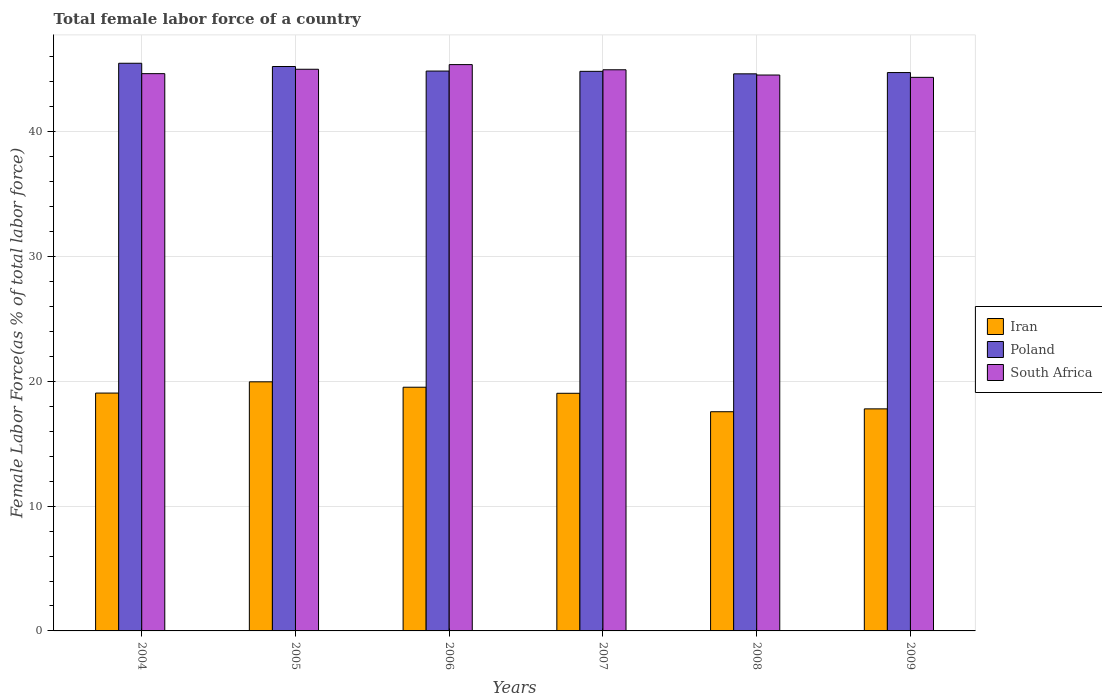How many groups of bars are there?
Your answer should be compact. 6. Are the number of bars on each tick of the X-axis equal?
Make the answer very short. Yes. How many bars are there on the 2nd tick from the left?
Offer a very short reply. 3. In how many cases, is the number of bars for a given year not equal to the number of legend labels?
Your response must be concise. 0. What is the percentage of female labor force in Poland in 2005?
Offer a terse response. 45.23. Across all years, what is the maximum percentage of female labor force in South Africa?
Make the answer very short. 45.38. Across all years, what is the minimum percentage of female labor force in Iran?
Your answer should be very brief. 17.56. In which year was the percentage of female labor force in Iran maximum?
Give a very brief answer. 2005. In which year was the percentage of female labor force in South Africa minimum?
Give a very brief answer. 2009. What is the total percentage of female labor force in Iran in the graph?
Your answer should be compact. 112.95. What is the difference between the percentage of female labor force in Iran in 2007 and that in 2008?
Ensure brevity in your answer.  1.48. What is the difference between the percentage of female labor force in Iran in 2008 and the percentage of female labor force in South Africa in 2006?
Offer a very short reply. -27.82. What is the average percentage of female labor force in South Africa per year?
Give a very brief answer. 44.82. In the year 2004, what is the difference between the percentage of female labor force in South Africa and percentage of female labor force in Iran?
Offer a very short reply. 25.6. In how many years, is the percentage of female labor force in Poland greater than 24 %?
Keep it short and to the point. 6. What is the ratio of the percentage of female labor force in South Africa in 2006 to that in 2007?
Offer a very short reply. 1.01. Is the percentage of female labor force in Iran in 2005 less than that in 2008?
Offer a terse response. No. Is the difference between the percentage of female labor force in South Africa in 2006 and 2009 greater than the difference between the percentage of female labor force in Iran in 2006 and 2009?
Offer a very short reply. No. What is the difference between the highest and the second highest percentage of female labor force in South Africa?
Your answer should be compact. 0.37. What is the difference between the highest and the lowest percentage of female labor force in South Africa?
Make the answer very short. 1.02. In how many years, is the percentage of female labor force in South Africa greater than the average percentage of female labor force in South Africa taken over all years?
Provide a succinct answer. 3. Is the sum of the percentage of female labor force in Iran in 2006 and 2008 greater than the maximum percentage of female labor force in South Africa across all years?
Offer a terse response. No. What does the 2nd bar from the left in 2004 represents?
Provide a short and direct response. Poland. What does the 3rd bar from the right in 2005 represents?
Ensure brevity in your answer.  Iran. Is it the case that in every year, the sum of the percentage of female labor force in Iran and percentage of female labor force in South Africa is greater than the percentage of female labor force in Poland?
Offer a very short reply. Yes. How many bars are there?
Ensure brevity in your answer.  18. Does the graph contain any zero values?
Give a very brief answer. No. What is the title of the graph?
Your answer should be very brief. Total female labor force of a country. What is the label or title of the X-axis?
Provide a short and direct response. Years. What is the label or title of the Y-axis?
Offer a very short reply. Female Labor Force(as % of total labor force). What is the Female Labor Force(as % of total labor force) of Iran in 2004?
Provide a succinct answer. 19.06. What is the Female Labor Force(as % of total labor force) of Poland in 2004?
Your answer should be compact. 45.49. What is the Female Labor Force(as % of total labor force) in South Africa in 2004?
Give a very brief answer. 44.66. What is the Female Labor Force(as % of total labor force) of Iran in 2005?
Make the answer very short. 19.96. What is the Female Labor Force(as % of total labor force) in Poland in 2005?
Give a very brief answer. 45.23. What is the Female Labor Force(as % of total labor force) in South Africa in 2005?
Your response must be concise. 45.01. What is the Female Labor Force(as % of total labor force) of Iran in 2006?
Offer a very short reply. 19.53. What is the Female Labor Force(as % of total labor force) in Poland in 2006?
Offer a very short reply. 44.86. What is the Female Labor Force(as % of total labor force) of South Africa in 2006?
Keep it short and to the point. 45.38. What is the Female Labor Force(as % of total labor force) of Iran in 2007?
Offer a terse response. 19.04. What is the Female Labor Force(as % of total labor force) of Poland in 2007?
Your answer should be compact. 44.84. What is the Female Labor Force(as % of total labor force) in South Africa in 2007?
Your answer should be very brief. 44.97. What is the Female Labor Force(as % of total labor force) of Iran in 2008?
Provide a short and direct response. 17.56. What is the Female Labor Force(as % of total labor force) in Poland in 2008?
Your answer should be very brief. 44.64. What is the Female Labor Force(as % of total labor force) in South Africa in 2008?
Ensure brevity in your answer.  44.54. What is the Female Labor Force(as % of total labor force) of Iran in 2009?
Give a very brief answer. 17.79. What is the Female Labor Force(as % of total labor force) in Poland in 2009?
Make the answer very short. 44.74. What is the Female Labor Force(as % of total labor force) of South Africa in 2009?
Make the answer very short. 44.36. Across all years, what is the maximum Female Labor Force(as % of total labor force) of Iran?
Offer a terse response. 19.96. Across all years, what is the maximum Female Labor Force(as % of total labor force) in Poland?
Your answer should be very brief. 45.49. Across all years, what is the maximum Female Labor Force(as % of total labor force) in South Africa?
Make the answer very short. 45.38. Across all years, what is the minimum Female Labor Force(as % of total labor force) of Iran?
Offer a very short reply. 17.56. Across all years, what is the minimum Female Labor Force(as % of total labor force) of Poland?
Offer a very short reply. 44.64. Across all years, what is the minimum Female Labor Force(as % of total labor force) of South Africa?
Provide a succinct answer. 44.36. What is the total Female Labor Force(as % of total labor force) in Iran in the graph?
Offer a terse response. 112.95. What is the total Female Labor Force(as % of total labor force) of Poland in the graph?
Provide a short and direct response. 269.8. What is the total Female Labor Force(as % of total labor force) of South Africa in the graph?
Offer a very short reply. 268.91. What is the difference between the Female Labor Force(as % of total labor force) of Iran in 2004 and that in 2005?
Ensure brevity in your answer.  -0.9. What is the difference between the Female Labor Force(as % of total labor force) in Poland in 2004 and that in 2005?
Your answer should be compact. 0.26. What is the difference between the Female Labor Force(as % of total labor force) in South Africa in 2004 and that in 2005?
Give a very brief answer. -0.35. What is the difference between the Female Labor Force(as % of total labor force) in Iran in 2004 and that in 2006?
Provide a succinct answer. -0.47. What is the difference between the Female Labor Force(as % of total labor force) in Poland in 2004 and that in 2006?
Give a very brief answer. 0.63. What is the difference between the Female Labor Force(as % of total labor force) of South Africa in 2004 and that in 2006?
Provide a succinct answer. -0.72. What is the difference between the Female Labor Force(as % of total labor force) of Iran in 2004 and that in 2007?
Your response must be concise. 0.02. What is the difference between the Female Labor Force(as % of total labor force) in Poland in 2004 and that in 2007?
Make the answer very short. 0.65. What is the difference between the Female Labor Force(as % of total labor force) in South Africa in 2004 and that in 2007?
Give a very brief answer. -0.31. What is the difference between the Female Labor Force(as % of total labor force) of Iran in 2004 and that in 2008?
Make the answer very short. 1.5. What is the difference between the Female Labor Force(as % of total labor force) of Poland in 2004 and that in 2008?
Offer a terse response. 0.85. What is the difference between the Female Labor Force(as % of total labor force) of South Africa in 2004 and that in 2008?
Give a very brief answer. 0.11. What is the difference between the Female Labor Force(as % of total labor force) of Iran in 2004 and that in 2009?
Offer a very short reply. 1.27. What is the difference between the Female Labor Force(as % of total labor force) in Poland in 2004 and that in 2009?
Your answer should be very brief. 0.74. What is the difference between the Female Labor Force(as % of total labor force) of South Africa in 2004 and that in 2009?
Offer a very short reply. 0.3. What is the difference between the Female Labor Force(as % of total labor force) in Iran in 2005 and that in 2006?
Offer a very short reply. 0.43. What is the difference between the Female Labor Force(as % of total labor force) of Poland in 2005 and that in 2006?
Offer a very short reply. 0.36. What is the difference between the Female Labor Force(as % of total labor force) of South Africa in 2005 and that in 2006?
Provide a short and direct response. -0.37. What is the difference between the Female Labor Force(as % of total labor force) in Iran in 2005 and that in 2007?
Offer a very short reply. 0.92. What is the difference between the Female Labor Force(as % of total labor force) of Poland in 2005 and that in 2007?
Offer a terse response. 0.39. What is the difference between the Female Labor Force(as % of total labor force) in South Africa in 2005 and that in 2007?
Offer a terse response. 0.04. What is the difference between the Female Labor Force(as % of total labor force) of Iran in 2005 and that in 2008?
Give a very brief answer. 2.4. What is the difference between the Female Labor Force(as % of total labor force) in Poland in 2005 and that in 2008?
Offer a very short reply. 0.59. What is the difference between the Female Labor Force(as % of total labor force) in South Africa in 2005 and that in 2008?
Ensure brevity in your answer.  0.46. What is the difference between the Female Labor Force(as % of total labor force) in Iran in 2005 and that in 2009?
Offer a terse response. 2.17. What is the difference between the Female Labor Force(as % of total labor force) of Poland in 2005 and that in 2009?
Provide a succinct answer. 0.48. What is the difference between the Female Labor Force(as % of total labor force) in South Africa in 2005 and that in 2009?
Make the answer very short. 0.65. What is the difference between the Female Labor Force(as % of total labor force) in Iran in 2006 and that in 2007?
Give a very brief answer. 0.49. What is the difference between the Female Labor Force(as % of total labor force) of Poland in 2006 and that in 2007?
Keep it short and to the point. 0.02. What is the difference between the Female Labor Force(as % of total labor force) of South Africa in 2006 and that in 2007?
Ensure brevity in your answer.  0.41. What is the difference between the Female Labor Force(as % of total labor force) of Iran in 2006 and that in 2008?
Make the answer very short. 1.96. What is the difference between the Female Labor Force(as % of total labor force) of Poland in 2006 and that in 2008?
Your answer should be compact. 0.22. What is the difference between the Female Labor Force(as % of total labor force) of South Africa in 2006 and that in 2008?
Your answer should be compact. 0.83. What is the difference between the Female Labor Force(as % of total labor force) of Iran in 2006 and that in 2009?
Your answer should be very brief. 1.73. What is the difference between the Female Labor Force(as % of total labor force) of Poland in 2006 and that in 2009?
Keep it short and to the point. 0.12. What is the difference between the Female Labor Force(as % of total labor force) of South Africa in 2006 and that in 2009?
Provide a succinct answer. 1.02. What is the difference between the Female Labor Force(as % of total labor force) of Iran in 2007 and that in 2008?
Offer a very short reply. 1.48. What is the difference between the Female Labor Force(as % of total labor force) in Poland in 2007 and that in 2008?
Offer a terse response. 0.2. What is the difference between the Female Labor Force(as % of total labor force) of South Africa in 2007 and that in 2008?
Ensure brevity in your answer.  0.42. What is the difference between the Female Labor Force(as % of total labor force) in Iran in 2007 and that in 2009?
Provide a short and direct response. 1.25. What is the difference between the Female Labor Force(as % of total labor force) of Poland in 2007 and that in 2009?
Your answer should be very brief. 0.1. What is the difference between the Female Labor Force(as % of total labor force) of South Africa in 2007 and that in 2009?
Make the answer very short. 0.61. What is the difference between the Female Labor Force(as % of total labor force) in Iran in 2008 and that in 2009?
Offer a very short reply. -0.23. What is the difference between the Female Labor Force(as % of total labor force) in Poland in 2008 and that in 2009?
Offer a terse response. -0.1. What is the difference between the Female Labor Force(as % of total labor force) of South Africa in 2008 and that in 2009?
Your response must be concise. 0.19. What is the difference between the Female Labor Force(as % of total labor force) in Iran in 2004 and the Female Labor Force(as % of total labor force) in Poland in 2005?
Provide a short and direct response. -26.17. What is the difference between the Female Labor Force(as % of total labor force) in Iran in 2004 and the Female Labor Force(as % of total labor force) in South Africa in 2005?
Your answer should be compact. -25.95. What is the difference between the Female Labor Force(as % of total labor force) of Poland in 2004 and the Female Labor Force(as % of total labor force) of South Africa in 2005?
Make the answer very short. 0.48. What is the difference between the Female Labor Force(as % of total labor force) in Iran in 2004 and the Female Labor Force(as % of total labor force) in Poland in 2006?
Provide a succinct answer. -25.8. What is the difference between the Female Labor Force(as % of total labor force) in Iran in 2004 and the Female Labor Force(as % of total labor force) in South Africa in 2006?
Keep it short and to the point. -26.32. What is the difference between the Female Labor Force(as % of total labor force) of Poland in 2004 and the Female Labor Force(as % of total labor force) of South Africa in 2006?
Provide a succinct answer. 0.11. What is the difference between the Female Labor Force(as % of total labor force) of Iran in 2004 and the Female Labor Force(as % of total labor force) of Poland in 2007?
Offer a very short reply. -25.78. What is the difference between the Female Labor Force(as % of total labor force) of Iran in 2004 and the Female Labor Force(as % of total labor force) of South Africa in 2007?
Offer a terse response. -25.91. What is the difference between the Female Labor Force(as % of total labor force) in Poland in 2004 and the Female Labor Force(as % of total labor force) in South Africa in 2007?
Your answer should be compact. 0.52. What is the difference between the Female Labor Force(as % of total labor force) of Iran in 2004 and the Female Labor Force(as % of total labor force) of Poland in 2008?
Provide a succinct answer. -25.58. What is the difference between the Female Labor Force(as % of total labor force) of Iran in 2004 and the Female Labor Force(as % of total labor force) of South Africa in 2008?
Provide a succinct answer. -25.49. What is the difference between the Female Labor Force(as % of total labor force) of Poland in 2004 and the Female Labor Force(as % of total labor force) of South Africa in 2008?
Your response must be concise. 0.94. What is the difference between the Female Labor Force(as % of total labor force) of Iran in 2004 and the Female Labor Force(as % of total labor force) of Poland in 2009?
Give a very brief answer. -25.68. What is the difference between the Female Labor Force(as % of total labor force) in Iran in 2004 and the Female Labor Force(as % of total labor force) in South Africa in 2009?
Keep it short and to the point. -25.3. What is the difference between the Female Labor Force(as % of total labor force) in Poland in 2004 and the Female Labor Force(as % of total labor force) in South Africa in 2009?
Make the answer very short. 1.13. What is the difference between the Female Labor Force(as % of total labor force) in Iran in 2005 and the Female Labor Force(as % of total labor force) in Poland in 2006?
Keep it short and to the point. -24.9. What is the difference between the Female Labor Force(as % of total labor force) in Iran in 2005 and the Female Labor Force(as % of total labor force) in South Africa in 2006?
Give a very brief answer. -25.42. What is the difference between the Female Labor Force(as % of total labor force) of Poland in 2005 and the Female Labor Force(as % of total labor force) of South Africa in 2006?
Provide a succinct answer. -0.15. What is the difference between the Female Labor Force(as % of total labor force) in Iran in 2005 and the Female Labor Force(as % of total labor force) in Poland in 2007?
Provide a succinct answer. -24.88. What is the difference between the Female Labor Force(as % of total labor force) of Iran in 2005 and the Female Labor Force(as % of total labor force) of South Africa in 2007?
Provide a short and direct response. -25. What is the difference between the Female Labor Force(as % of total labor force) in Poland in 2005 and the Female Labor Force(as % of total labor force) in South Africa in 2007?
Your answer should be very brief. 0.26. What is the difference between the Female Labor Force(as % of total labor force) of Iran in 2005 and the Female Labor Force(as % of total labor force) of Poland in 2008?
Provide a succinct answer. -24.68. What is the difference between the Female Labor Force(as % of total labor force) in Iran in 2005 and the Female Labor Force(as % of total labor force) in South Africa in 2008?
Provide a succinct answer. -24.58. What is the difference between the Female Labor Force(as % of total labor force) in Poland in 2005 and the Female Labor Force(as % of total labor force) in South Africa in 2008?
Your response must be concise. 0.68. What is the difference between the Female Labor Force(as % of total labor force) in Iran in 2005 and the Female Labor Force(as % of total labor force) in Poland in 2009?
Provide a short and direct response. -24.78. What is the difference between the Female Labor Force(as % of total labor force) of Iran in 2005 and the Female Labor Force(as % of total labor force) of South Africa in 2009?
Offer a very short reply. -24.4. What is the difference between the Female Labor Force(as % of total labor force) of Poland in 2005 and the Female Labor Force(as % of total labor force) of South Africa in 2009?
Your response must be concise. 0.87. What is the difference between the Female Labor Force(as % of total labor force) in Iran in 2006 and the Female Labor Force(as % of total labor force) in Poland in 2007?
Your answer should be compact. -25.31. What is the difference between the Female Labor Force(as % of total labor force) in Iran in 2006 and the Female Labor Force(as % of total labor force) in South Africa in 2007?
Your answer should be very brief. -25.44. What is the difference between the Female Labor Force(as % of total labor force) of Poland in 2006 and the Female Labor Force(as % of total labor force) of South Africa in 2007?
Offer a very short reply. -0.1. What is the difference between the Female Labor Force(as % of total labor force) of Iran in 2006 and the Female Labor Force(as % of total labor force) of Poland in 2008?
Your answer should be very brief. -25.11. What is the difference between the Female Labor Force(as % of total labor force) of Iran in 2006 and the Female Labor Force(as % of total labor force) of South Africa in 2008?
Give a very brief answer. -25.02. What is the difference between the Female Labor Force(as % of total labor force) of Poland in 2006 and the Female Labor Force(as % of total labor force) of South Africa in 2008?
Offer a very short reply. 0.32. What is the difference between the Female Labor Force(as % of total labor force) in Iran in 2006 and the Female Labor Force(as % of total labor force) in Poland in 2009?
Offer a terse response. -25.21. What is the difference between the Female Labor Force(as % of total labor force) of Iran in 2006 and the Female Labor Force(as % of total labor force) of South Africa in 2009?
Your answer should be very brief. -24.83. What is the difference between the Female Labor Force(as % of total labor force) in Poland in 2006 and the Female Labor Force(as % of total labor force) in South Africa in 2009?
Make the answer very short. 0.5. What is the difference between the Female Labor Force(as % of total labor force) of Iran in 2007 and the Female Labor Force(as % of total labor force) of Poland in 2008?
Your answer should be very brief. -25.6. What is the difference between the Female Labor Force(as % of total labor force) in Iran in 2007 and the Female Labor Force(as % of total labor force) in South Africa in 2008?
Make the answer very short. -25.5. What is the difference between the Female Labor Force(as % of total labor force) of Poland in 2007 and the Female Labor Force(as % of total labor force) of South Africa in 2008?
Your answer should be very brief. 0.3. What is the difference between the Female Labor Force(as % of total labor force) of Iran in 2007 and the Female Labor Force(as % of total labor force) of Poland in 2009?
Offer a terse response. -25.7. What is the difference between the Female Labor Force(as % of total labor force) of Iran in 2007 and the Female Labor Force(as % of total labor force) of South Africa in 2009?
Give a very brief answer. -25.32. What is the difference between the Female Labor Force(as % of total labor force) of Poland in 2007 and the Female Labor Force(as % of total labor force) of South Africa in 2009?
Offer a terse response. 0.48. What is the difference between the Female Labor Force(as % of total labor force) in Iran in 2008 and the Female Labor Force(as % of total labor force) in Poland in 2009?
Your response must be concise. -27.18. What is the difference between the Female Labor Force(as % of total labor force) of Iran in 2008 and the Female Labor Force(as % of total labor force) of South Africa in 2009?
Offer a very short reply. -26.79. What is the difference between the Female Labor Force(as % of total labor force) of Poland in 2008 and the Female Labor Force(as % of total labor force) of South Africa in 2009?
Your answer should be very brief. 0.28. What is the average Female Labor Force(as % of total labor force) of Iran per year?
Keep it short and to the point. 18.82. What is the average Female Labor Force(as % of total labor force) of Poland per year?
Provide a short and direct response. 44.97. What is the average Female Labor Force(as % of total labor force) in South Africa per year?
Give a very brief answer. 44.82. In the year 2004, what is the difference between the Female Labor Force(as % of total labor force) in Iran and Female Labor Force(as % of total labor force) in Poland?
Provide a succinct answer. -26.43. In the year 2004, what is the difference between the Female Labor Force(as % of total labor force) in Iran and Female Labor Force(as % of total labor force) in South Africa?
Your response must be concise. -25.6. In the year 2004, what is the difference between the Female Labor Force(as % of total labor force) of Poland and Female Labor Force(as % of total labor force) of South Africa?
Ensure brevity in your answer.  0.83. In the year 2005, what is the difference between the Female Labor Force(as % of total labor force) in Iran and Female Labor Force(as % of total labor force) in Poland?
Offer a terse response. -25.27. In the year 2005, what is the difference between the Female Labor Force(as % of total labor force) in Iran and Female Labor Force(as % of total labor force) in South Africa?
Your answer should be compact. -25.05. In the year 2005, what is the difference between the Female Labor Force(as % of total labor force) in Poland and Female Labor Force(as % of total labor force) in South Africa?
Ensure brevity in your answer.  0.22. In the year 2006, what is the difference between the Female Labor Force(as % of total labor force) of Iran and Female Labor Force(as % of total labor force) of Poland?
Provide a succinct answer. -25.33. In the year 2006, what is the difference between the Female Labor Force(as % of total labor force) of Iran and Female Labor Force(as % of total labor force) of South Africa?
Give a very brief answer. -25.85. In the year 2006, what is the difference between the Female Labor Force(as % of total labor force) in Poland and Female Labor Force(as % of total labor force) in South Africa?
Make the answer very short. -0.52. In the year 2007, what is the difference between the Female Labor Force(as % of total labor force) of Iran and Female Labor Force(as % of total labor force) of Poland?
Give a very brief answer. -25.8. In the year 2007, what is the difference between the Female Labor Force(as % of total labor force) in Iran and Female Labor Force(as % of total labor force) in South Africa?
Provide a short and direct response. -25.92. In the year 2007, what is the difference between the Female Labor Force(as % of total labor force) of Poland and Female Labor Force(as % of total labor force) of South Africa?
Provide a succinct answer. -0.13. In the year 2008, what is the difference between the Female Labor Force(as % of total labor force) in Iran and Female Labor Force(as % of total labor force) in Poland?
Your response must be concise. -27.08. In the year 2008, what is the difference between the Female Labor Force(as % of total labor force) in Iran and Female Labor Force(as % of total labor force) in South Africa?
Ensure brevity in your answer.  -26.98. In the year 2008, what is the difference between the Female Labor Force(as % of total labor force) of Poland and Female Labor Force(as % of total labor force) of South Africa?
Make the answer very short. 0.1. In the year 2009, what is the difference between the Female Labor Force(as % of total labor force) of Iran and Female Labor Force(as % of total labor force) of Poland?
Offer a very short reply. -26.95. In the year 2009, what is the difference between the Female Labor Force(as % of total labor force) in Iran and Female Labor Force(as % of total labor force) in South Africa?
Provide a succinct answer. -26.56. In the year 2009, what is the difference between the Female Labor Force(as % of total labor force) of Poland and Female Labor Force(as % of total labor force) of South Africa?
Keep it short and to the point. 0.38. What is the ratio of the Female Labor Force(as % of total labor force) in Iran in 2004 to that in 2005?
Ensure brevity in your answer.  0.95. What is the ratio of the Female Labor Force(as % of total labor force) in Poland in 2004 to that in 2005?
Offer a terse response. 1.01. What is the ratio of the Female Labor Force(as % of total labor force) in Poland in 2004 to that in 2006?
Provide a short and direct response. 1.01. What is the ratio of the Female Labor Force(as % of total labor force) of South Africa in 2004 to that in 2006?
Give a very brief answer. 0.98. What is the ratio of the Female Labor Force(as % of total labor force) of Poland in 2004 to that in 2007?
Offer a terse response. 1.01. What is the ratio of the Female Labor Force(as % of total labor force) in Iran in 2004 to that in 2008?
Your answer should be compact. 1.09. What is the ratio of the Female Labor Force(as % of total labor force) of Poland in 2004 to that in 2008?
Your answer should be compact. 1.02. What is the ratio of the Female Labor Force(as % of total labor force) in South Africa in 2004 to that in 2008?
Your answer should be very brief. 1. What is the ratio of the Female Labor Force(as % of total labor force) of Iran in 2004 to that in 2009?
Your answer should be very brief. 1.07. What is the ratio of the Female Labor Force(as % of total labor force) of Poland in 2004 to that in 2009?
Your response must be concise. 1.02. What is the ratio of the Female Labor Force(as % of total labor force) of Iran in 2005 to that in 2006?
Make the answer very short. 1.02. What is the ratio of the Female Labor Force(as % of total labor force) of Poland in 2005 to that in 2006?
Offer a very short reply. 1.01. What is the ratio of the Female Labor Force(as % of total labor force) in South Africa in 2005 to that in 2006?
Your response must be concise. 0.99. What is the ratio of the Female Labor Force(as % of total labor force) in Iran in 2005 to that in 2007?
Make the answer very short. 1.05. What is the ratio of the Female Labor Force(as % of total labor force) in Poland in 2005 to that in 2007?
Your answer should be very brief. 1.01. What is the ratio of the Female Labor Force(as % of total labor force) in Iran in 2005 to that in 2008?
Keep it short and to the point. 1.14. What is the ratio of the Female Labor Force(as % of total labor force) of Poland in 2005 to that in 2008?
Your response must be concise. 1.01. What is the ratio of the Female Labor Force(as % of total labor force) of South Africa in 2005 to that in 2008?
Give a very brief answer. 1.01. What is the ratio of the Female Labor Force(as % of total labor force) in Iran in 2005 to that in 2009?
Offer a very short reply. 1.12. What is the ratio of the Female Labor Force(as % of total labor force) of Poland in 2005 to that in 2009?
Give a very brief answer. 1.01. What is the ratio of the Female Labor Force(as % of total labor force) of South Africa in 2005 to that in 2009?
Your answer should be very brief. 1.01. What is the ratio of the Female Labor Force(as % of total labor force) in Iran in 2006 to that in 2007?
Offer a very short reply. 1.03. What is the ratio of the Female Labor Force(as % of total labor force) of South Africa in 2006 to that in 2007?
Give a very brief answer. 1.01. What is the ratio of the Female Labor Force(as % of total labor force) in Iran in 2006 to that in 2008?
Offer a terse response. 1.11. What is the ratio of the Female Labor Force(as % of total labor force) in Poland in 2006 to that in 2008?
Provide a succinct answer. 1. What is the ratio of the Female Labor Force(as % of total labor force) of South Africa in 2006 to that in 2008?
Provide a short and direct response. 1.02. What is the ratio of the Female Labor Force(as % of total labor force) of Iran in 2006 to that in 2009?
Your response must be concise. 1.1. What is the ratio of the Female Labor Force(as % of total labor force) of South Africa in 2006 to that in 2009?
Your answer should be very brief. 1.02. What is the ratio of the Female Labor Force(as % of total labor force) of Iran in 2007 to that in 2008?
Your answer should be compact. 1.08. What is the ratio of the Female Labor Force(as % of total labor force) of Poland in 2007 to that in 2008?
Provide a short and direct response. 1. What is the ratio of the Female Labor Force(as % of total labor force) in South Africa in 2007 to that in 2008?
Offer a terse response. 1.01. What is the ratio of the Female Labor Force(as % of total labor force) in Iran in 2007 to that in 2009?
Ensure brevity in your answer.  1.07. What is the ratio of the Female Labor Force(as % of total labor force) in South Africa in 2007 to that in 2009?
Keep it short and to the point. 1.01. What is the ratio of the Female Labor Force(as % of total labor force) of Iran in 2008 to that in 2009?
Offer a very short reply. 0.99. What is the difference between the highest and the second highest Female Labor Force(as % of total labor force) of Iran?
Ensure brevity in your answer.  0.43. What is the difference between the highest and the second highest Female Labor Force(as % of total labor force) in Poland?
Your response must be concise. 0.26. What is the difference between the highest and the second highest Female Labor Force(as % of total labor force) of South Africa?
Provide a succinct answer. 0.37. What is the difference between the highest and the lowest Female Labor Force(as % of total labor force) in Iran?
Provide a short and direct response. 2.4. What is the difference between the highest and the lowest Female Labor Force(as % of total labor force) of Poland?
Provide a short and direct response. 0.85. What is the difference between the highest and the lowest Female Labor Force(as % of total labor force) in South Africa?
Your response must be concise. 1.02. 